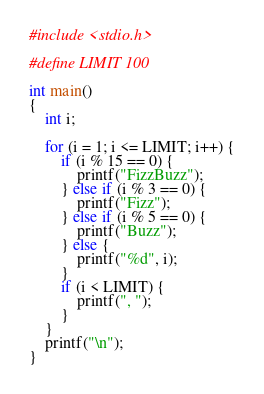Convert code to text. <code><loc_0><loc_0><loc_500><loc_500><_C_>#include <stdio.h>

#define LIMIT 100

int main()
{
	int i;

	for (i = 1; i <= LIMIT; i++) {
		if (i % 15 == 0) {
			printf("FizzBuzz");
		} else if (i % 3 == 0) {
			printf("Fizz");
		} else if (i % 5 == 0) {
			printf("Buzz");
		} else {
			printf("%d", i);
		}
		if (i < LIMIT) {
			printf(", ");
		}
	}
	printf("\n");
}
</code> 